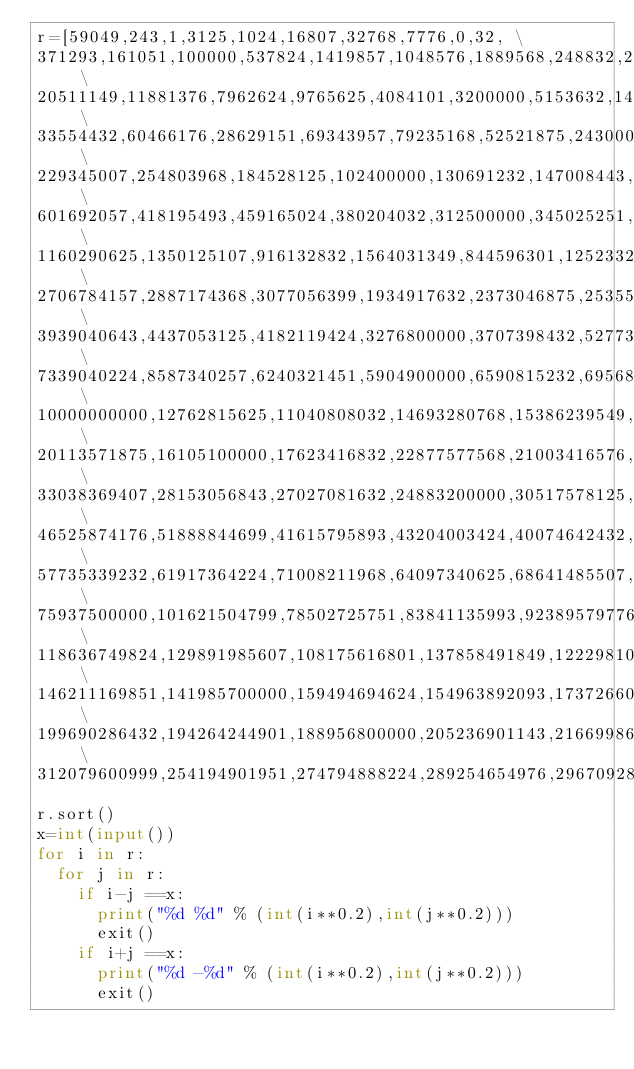Convert code to text. <code><loc_0><loc_0><loc_500><loc_500><_Python_>r=[59049,243,1,3125,1024,16807,32768,7776,0,32, \
371293,161051,100000,537824,1419857,1048576,1889568,248832,2476099,759375, \
20511149,11881376,7962624,9765625,4084101,3200000,5153632,14348907,17210368,6436343, \
33554432,60466176,28629151,69343957,79235168,52521875,24300000,45435424,90224199,39135393, \
229345007,254803968,184528125,102400000,130691232,147008443,205962976,164916224,282475249,115856201, \
601692057,418195493,459165024,380204032,312500000,345025251,714924299,503284375,550731776,656356768, \
1160290625,1350125107,916132832,1564031349,844596301,1252332576,1453933568,777600000,992436543,1073741824, \
2706784157,2887174368,3077056399,1934917632,2373046875,2535525376,2219006624,2073071593,1804229351,1680700000, \
3939040643,4437053125,4182119424,3276800000,3707398432,5277319168,5584059449,3486784401,4704270176,4984209207, \
7339040224,8587340257,6240321451,5904900000,6590815232,6956883693,7737809375,8153726976,9509900499,9039207968, \
10000000000,12762815625,11040808032,14693280768,15386239549,11592740743,14025517307,13382255776,12166529024,10510100501, \
20113571875,16105100000,17623416832,22877577568,21003416576,18424351793,21924480357,23863536599,19254145824,16850581551, \
33038369407,28153056843,27027081632,24883200000,30517578125,35723051649,34359738368,25937424601,31757969376,29316250624, \
46525874176,51888844699,41615795893,43204003424,40074642432,38579489651,44840334375,37129300000,48261724457,50049003168, \
57735339232,61917364224,71008211968,64097340625,68641485507,55730836701,66338290976,53782400000,73439775749,59797108943, \
75937500000,101621504799,78502725751,83841135993,92389579776,95388992557,89466096875,81136812032,98465804768,86617093024, \
118636749824,129891985607,108175616801,137858491849,122298103125,133827821568,115063617043,111577100832,104857600000,126049300576, \
146211169851,141985700000,159494694624,154963892093,173726604657,150536645632,168874213376,164130859375,178689902368,183765996899, \
199690286432,194264244901,188956800000,205236901143,216699865625,222620278176,210906087424,241162079949,234849287168,228669389707, \
312079600999,254194901951,274794888224,289254654976,296709280757,267785184193,304316815968,260919263232,281950621875,247609900000]
r.sort()
x=int(input())
for i in r:
  for j in r:
    if i-j ==x:
      print("%d %d" % (int(i**0.2),int(j**0.2)))
      exit()
    if i+j ==x:
      print("%d -%d" % (int(i**0.2),int(j**0.2)))
      exit()</code> 